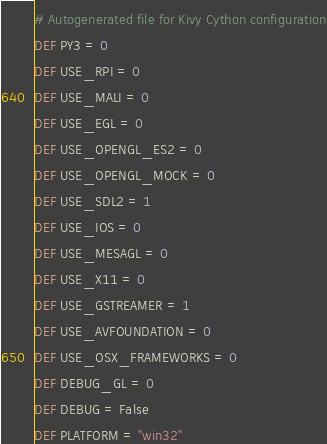Convert code to text. <code><loc_0><loc_0><loc_500><loc_500><_Cython_># Autogenerated file for Kivy Cython configuration
DEF PY3 = 0
DEF USE_RPI = 0
DEF USE_MALI = 0
DEF USE_EGL = 0
DEF USE_OPENGL_ES2 = 0
DEF USE_OPENGL_MOCK = 0
DEF USE_SDL2 = 1
DEF USE_IOS = 0
DEF USE_MESAGL = 0
DEF USE_X11 = 0
DEF USE_GSTREAMER = 1
DEF USE_AVFOUNDATION = 0
DEF USE_OSX_FRAMEWORKS = 0
DEF DEBUG_GL = 0
DEF DEBUG = False
DEF PLATFORM = "win32"
</code> 